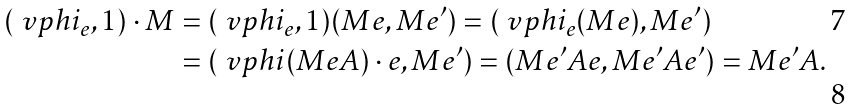<formula> <loc_0><loc_0><loc_500><loc_500>( \ v p h i _ { e } , 1 ) \cdot M & = ( \ v p h i _ { e } , 1 ) ( M e , M e ^ { \prime } ) = ( \ v p h i _ { e } ( M e ) , M e ^ { \prime } ) \\ & = ( \ v p h i ( M e A ) \cdot e , M e ^ { \prime } ) = ( M e ^ { \prime } A e , M e ^ { \prime } A e ^ { \prime } ) = M e ^ { \prime } A .</formula> 